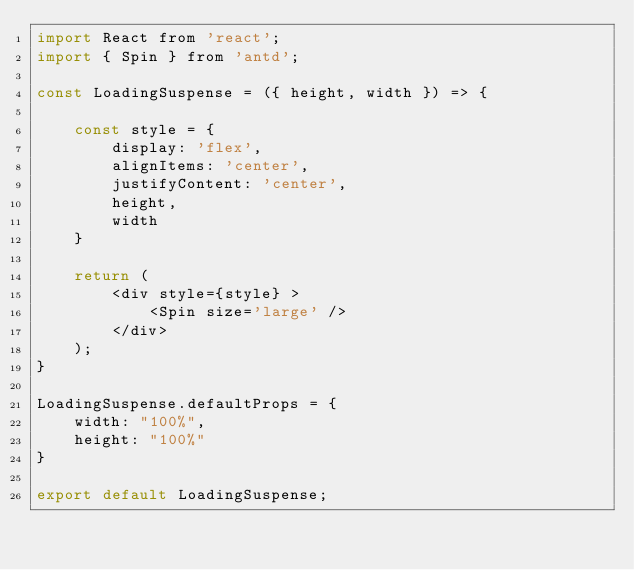<code> <loc_0><loc_0><loc_500><loc_500><_JavaScript_>import React from 'react';
import { Spin } from 'antd';

const LoadingSuspense = ({ height, width }) => {

    const style = {
        display: 'flex',
        alignItems: 'center',
        justifyContent: 'center',
        height,
        width
    }

    return (
        <div style={style} >
            <Spin size='large' />
        </div>
    );
}

LoadingSuspense.defaultProps = {
    width: "100%",
    height: "100%"
}

export default LoadingSuspense;</code> 